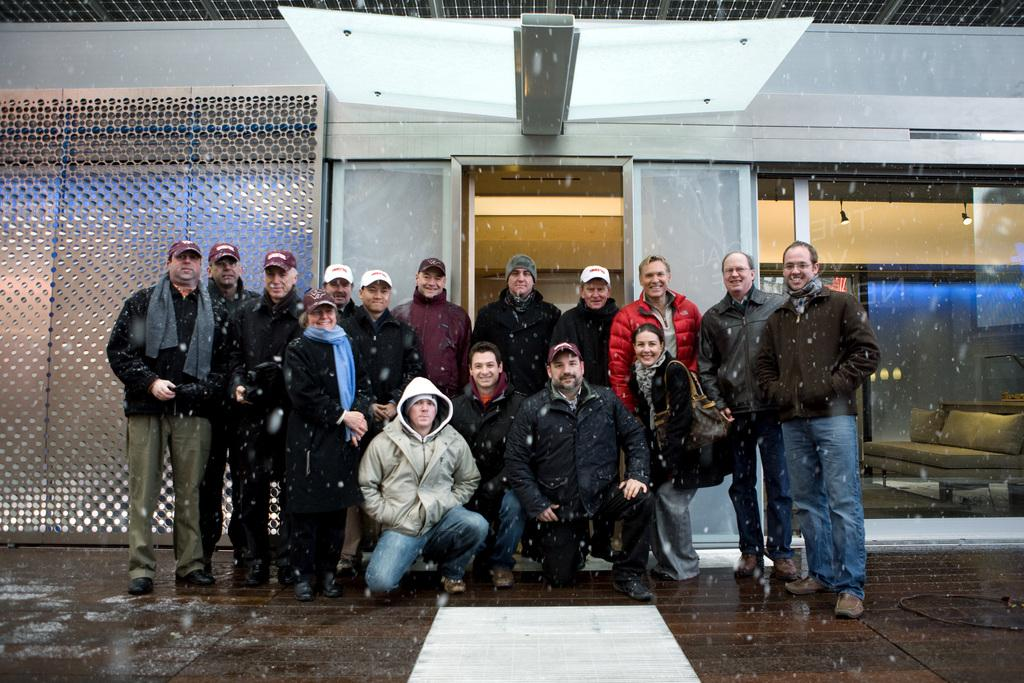What are the people in the image doing? The people in the image are posing. What object in the image has a glass element? There is a glass element in the image, and it is part of a structure that allows lights to be visible through it. What type of furniture is in the image? There is a sofa in the image. What is on the left side of the image? There is a wall on the left side of the image. What part of the room can be seen at the bottom of the image? The floor is visible at the bottom of the image. What type of authority figure can be seen in the image? There is no authority figure present in the image. What kind of squirrel is sitting on the sofa in the image? There is no squirrel present in the image. 